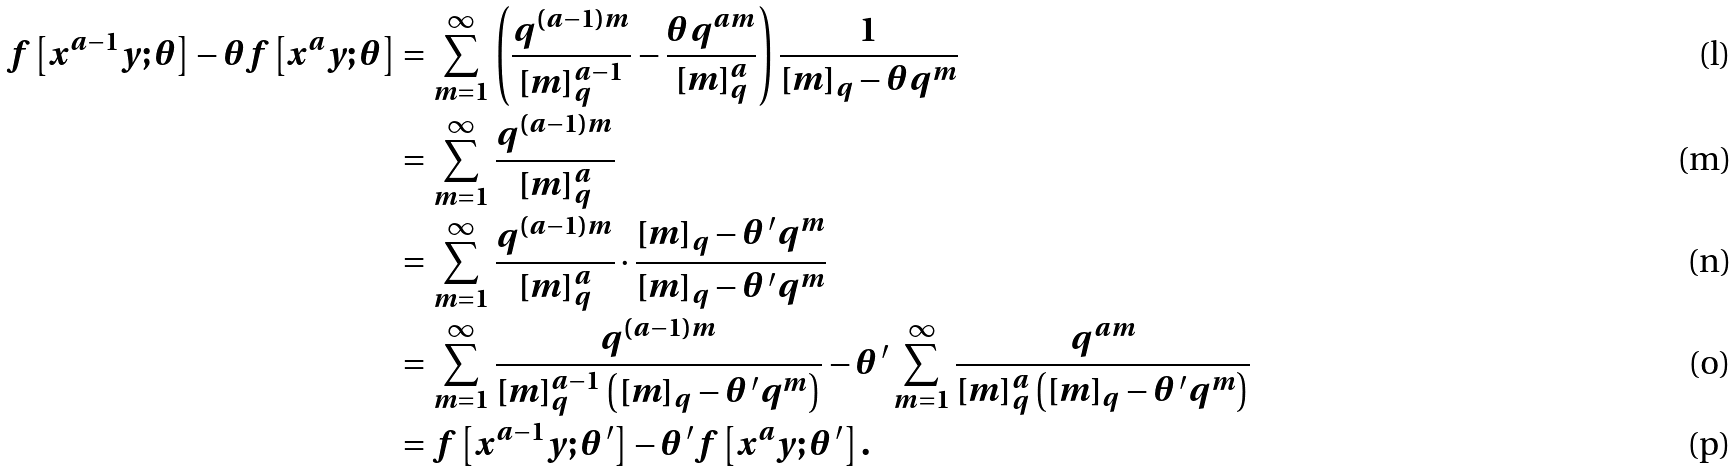<formula> <loc_0><loc_0><loc_500><loc_500>f \left [ x ^ { a - 1 } y ; \theta \right ] - \theta f \left [ x ^ { a } y ; \theta \right ] & = \sum _ { m = 1 } ^ { \infty } \left ( \frac { q ^ { ( a - 1 ) m } } { [ m ] _ { q } ^ { a - 1 } } - \frac { \theta q ^ { a m } } { [ m ] _ { q } ^ { a } } \right ) \frac { 1 } { [ m ] _ { q } - \theta q ^ { m } } \\ & = \sum _ { m = 1 } ^ { \infty } \frac { q ^ { ( a - 1 ) m } } { [ m ] _ { q } ^ { a } } \\ & = \sum _ { m = 1 } ^ { \infty } \frac { q ^ { ( a - 1 ) m } } { [ m ] _ { q } ^ { a } } \cdot \frac { [ m ] _ { q } - \theta \, ^ { \prime } q ^ { m } } { [ m ] _ { q } - \theta \, ^ { \prime } q ^ { m } } \\ & = \sum _ { m = 1 } ^ { \infty } \frac { q ^ { ( a - 1 ) m } } { [ m ] _ { q } ^ { a - 1 } \left ( [ m ] _ { q } - \theta \, ^ { \prime } q ^ { m } \right ) } - \theta \, ^ { \prime } \sum _ { m = 1 } ^ { \infty } \frac { q ^ { a m } } { [ m ] _ { q } ^ { a } \left ( [ m ] _ { q } - \theta \, ^ { \prime } q ^ { m } \right ) } \\ & = f \left [ x ^ { a - 1 } y ; \theta \, ^ { \prime } \right ] - \theta \, ^ { \prime } f \left [ x ^ { a } y ; \theta \, ^ { \prime } \right ] .</formula> 